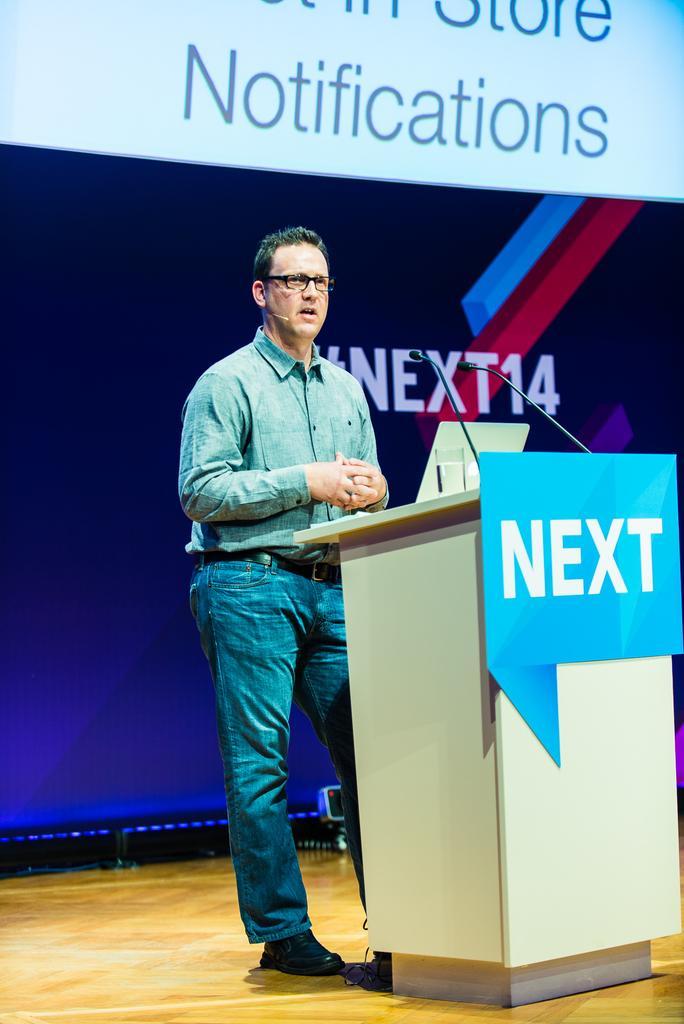Can you describe this image briefly? In this image, we can see a person wearing clothes and standing in front of the podium. In the background, we can see some text. 